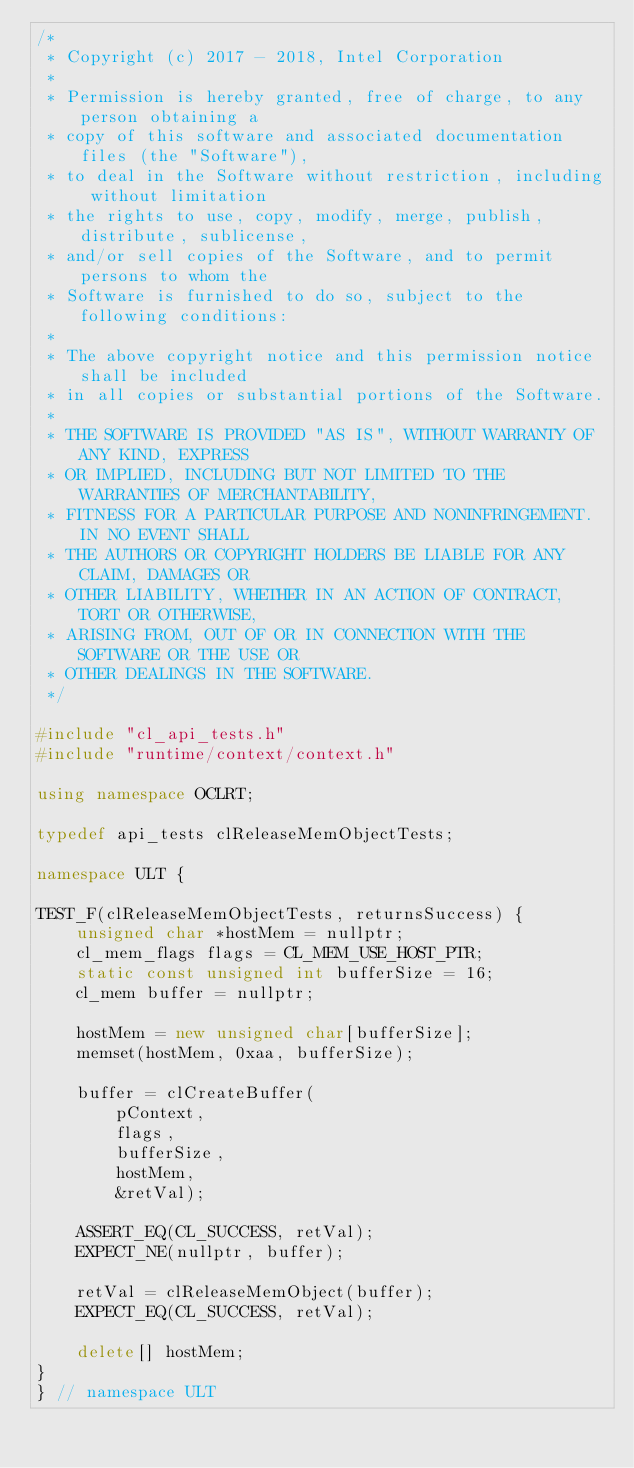<code> <loc_0><loc_0><loc_500><loc_500><_C++_>/*
 * Copyright (c) 2017 - 2018, Intel Corporation
 *
 * Permission is hereby granted, free of charge, to any person obtaining a
 * copy of this software and associated documentation files (the "Software"),
 * to deal in the Software without restriction, including without limitation
 * the rights to use, copy, modify, merge, publish, distribute, sublicense,
 * and/or sell copies of the Software, and to permit persons to whom the
 * Software is furnished to do so, subject to the following conditions:
 *
 * The above copyright notice and this permission notice shall be included
 * in all copies or substantial portions of the Software.
 *
 * THE SOFTWARE IS PROVIDED "AS IS", WITHOUT WARRANTY OF ANY KIND, EXPRESS
 * OR IMPLIED, INCLUDING BUT NOT LIMITED TO THE WARRANTIES OF MERCHANTABILITY,
 * FITNESS FOR A PARTICULAR PURPOSE AND NONINFRINGEMENT. IN NO EVENT SHALL
 * THE AUTHORS OR COPYRIGHT HOLDERS BE LIABLE FOR ANY CLAIM, DAMAGES OR
 * OTHER LIABILITY, WHETHER IN AN ACTION OF CONTRACT, TORT OR OTHERWISE,
 * ARISING FROM, OUT OF OR IN CONNECTION WITH THE SOFTWARE OR THE USE OR
 * OTHER DEALINGS IN THE SOFTWARE.
 */

#include "cl_api_tests.h"
#include "runtime/context/context.h"

using namespace OCLRT;

typedef api_tests clReleaseMemObjectTests;

namespace ULT {

TEST_F(clReleaseMemObjectTests, returnsSuccess) {
    unsigned char *hostMem = nullptr;
    cl_mem_flags flags = CL_MEM_USE_HOST_PTR;
    static const unsigned int bufferSize = 16;
    cl_mem buffer = nullptr;

    hostMem = new unsigned char[bufferSize];
    memset(hostMem, 0xaa, bufferSize);

    buffer = clCreateBuffer(
        pContext,
        flags,
        bufferSize,
        hostMem,
        &retVal);

    ASSERT_EQ(CL_SUCCESS, retVal);
    EXPECT_NE(nullptr, buffer);

    retVal = clReleaseMemObject(buffer);
    EXPECT_EQ(CL_SUCCESS, retVal);

    delete[] hostMem;
}
} // namespace ULT
</code> 